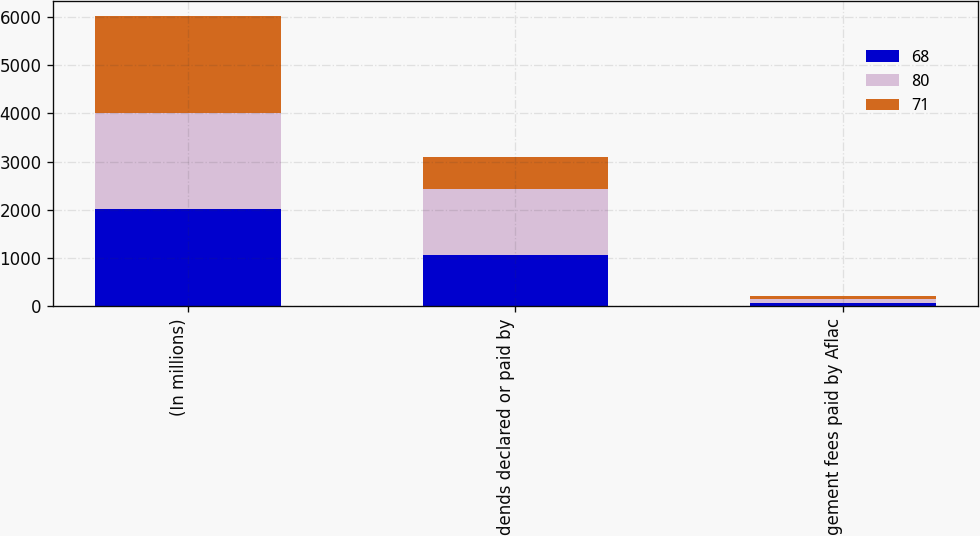Convert chart. <chart><loc_0><loc_0><loc_500><loc_500><stacked_bar_chart><ecel><fcel>(In millions)<fcel>Dividends declared or paid by<fcel>Management fees paid by Aflac<nl><fcel>68<fcel>2008<fcel>1062<fcel>71<nl><fcel>80<fcel>2007<fcel>1362<fcel>80<nl><fcel>71<fcel>2006<fcel>665<fcel>68<nl></chart> 